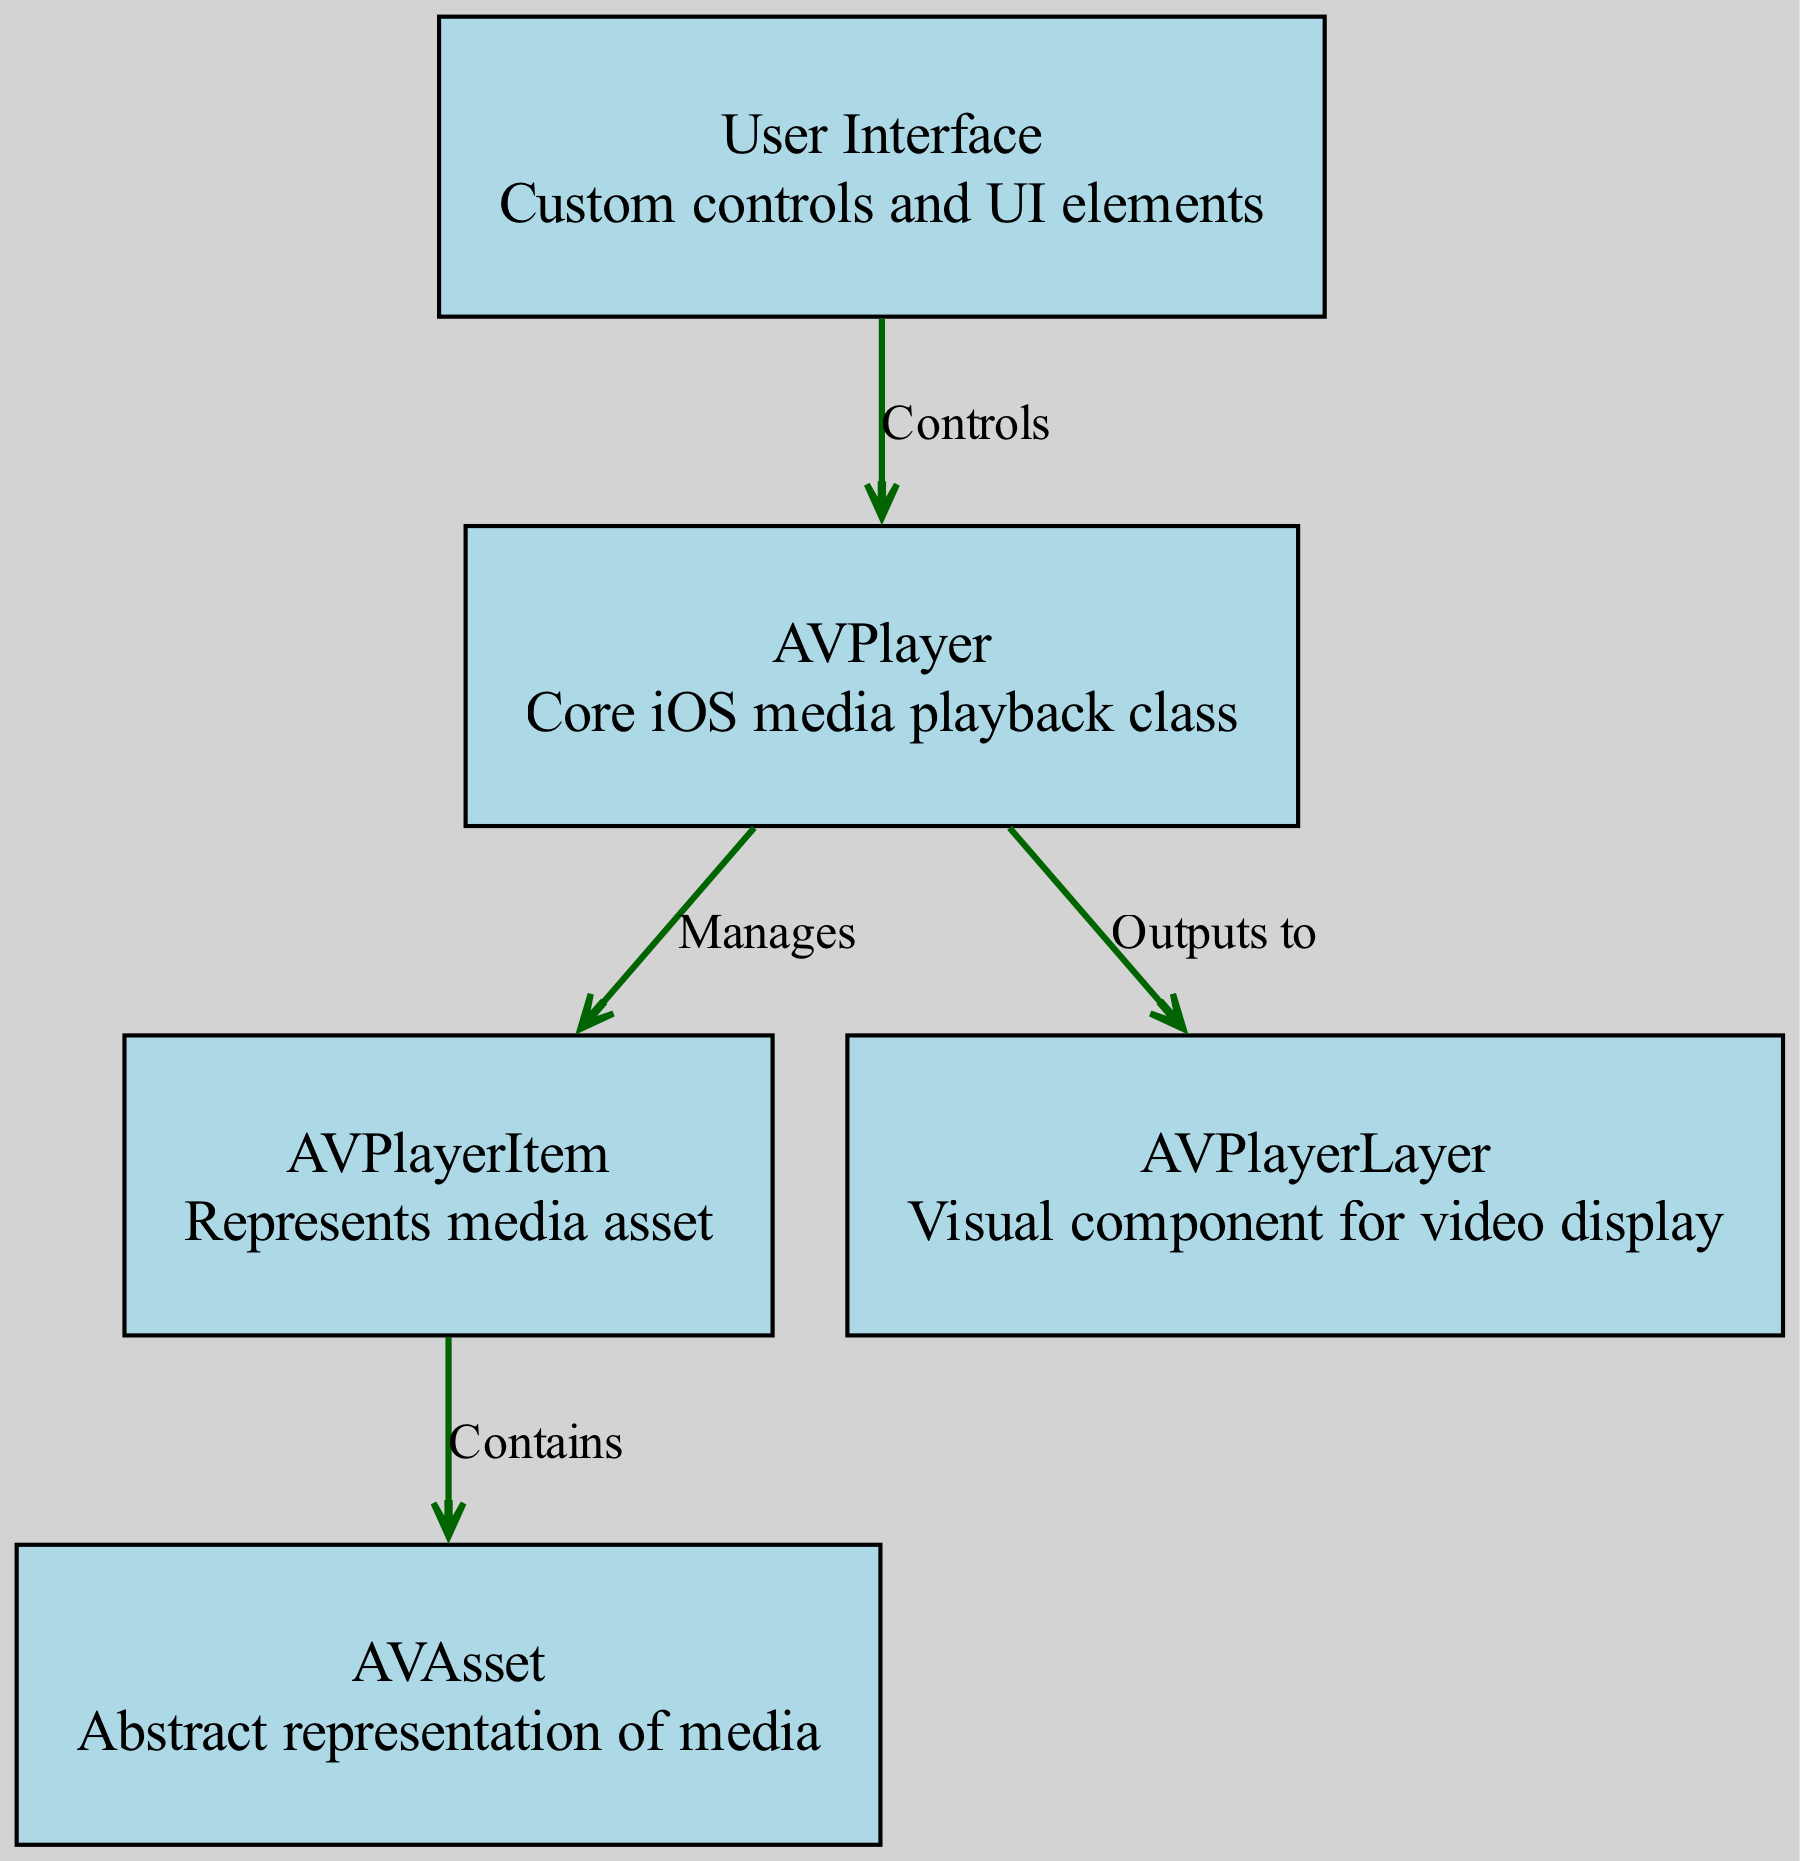What is the core iOS media playback class? The node labeled "AVPlayer" is described as the core iOS media playback class in the diagram, indicating its primary role.
Answer: AVPlayer How many nodes are present in the diagram? By counting the nodes listed in the diagram, there are five distinct nodes representing components of the media player architecture.
Answer: 5 What does AVPlayerItem represent? The node labeled "AVPlayerItem" is defined in the diagram as representing a media asset, specifying its function within the media player architecture.
Answer: Media asset Which node does the User Interface control? The edge from node "User Interface" to node "AVPlayer" indicates that the user interface directly controls the AVPlayer, making it the focus of user interactions.
Answer: AVPlayer What relationship does AVPlayer have with AVPlayerItem? The diagram shows that AVPlayer manages the AVPlayerItem, suggesting a one-to-many relationship where the AVPlayer maintains control over one or more AVPlayerItems.
Answer: Manages Which node serves as a visual component for video display? The node labeled "AVPlayerLayer" is described as the visual component for video display, indicating its purpose within the architecture of the media player.
Answer: AVPlayerLayer What does AVPlayerItem contain? The diagram specifies that the AVPlayerItem contains the AVAsset, indicating its role in storing the abstraction of the media content.
Answer: AVAsset What does AVPlayer output to? According to the diagram, AVPlayer outputs to AVPlayerLayer, establishing the flow of media data to the visual representation of the content.
Answer: AVPlayerLayer What is the color of the nodes in the diagram? All nodes are colored light blue as indicated by the description of their appearances in the formatting attributes provided in the diagram.
Answer: Light blue 